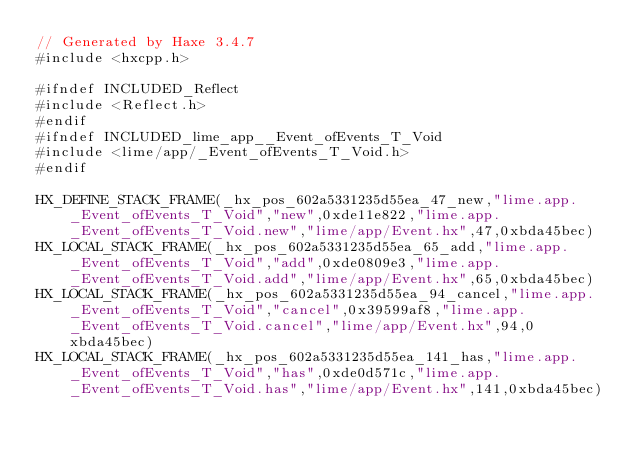Convert code to text. <code><loc_0><loc_0><loc_500><loc_500><_C++_>// Generated by Haxe 3.4.7
#include <hxcpp.h>

#ifndef INCLUDED_Reflect
#include <Reflect.h>
#endif
#ifndef INCLUDED_lime_app__Event_ofEvents_T_Void
#include <lime/app/_Event_ofEvents_T_Void.h>
#endif

HX_DEFINE_STACK_FRAME(_hx_pos_602a5331235d55ea_47_new,"lime.app._Event_ofEvents_T_Void","new",0xde11e822,"lime.app._Event_ofEvents_T_Void.new","lime/app/Event.hx",47,0xbda45bec)
HX_LOCAL_STACK_FRAME(_hx_pos_602a5331235d55ea_65_add,"lime.app._Event_ofEvents_T_Void","add",0xde0809e3,"lime.app._Event_ofEvents_T_Void.add","lime/app/Event.hx",65,0xbda45bec)
HX_LOCAL_STACK_FRAME(_hx_pos_602a5331235d55ea_94_cancel,"lime.app._Event_ofEvents_T_Void","cancel",0x39599af8,"lime.app._Event_ofEvents_T_Void.cancel","lime/app/Event.hx",94,0xbda45bec)
HX_LOCAL_STACK_FRAME(_hx_pos_602a5331235d55ea_141_has,"lime.app._Event_ofEvents_T_Void","has",0xde0d571c,"lime.app._Event_ofEvents_T_Void.has","lime/app/Event.hx",141,0xbda45bec)</code> 